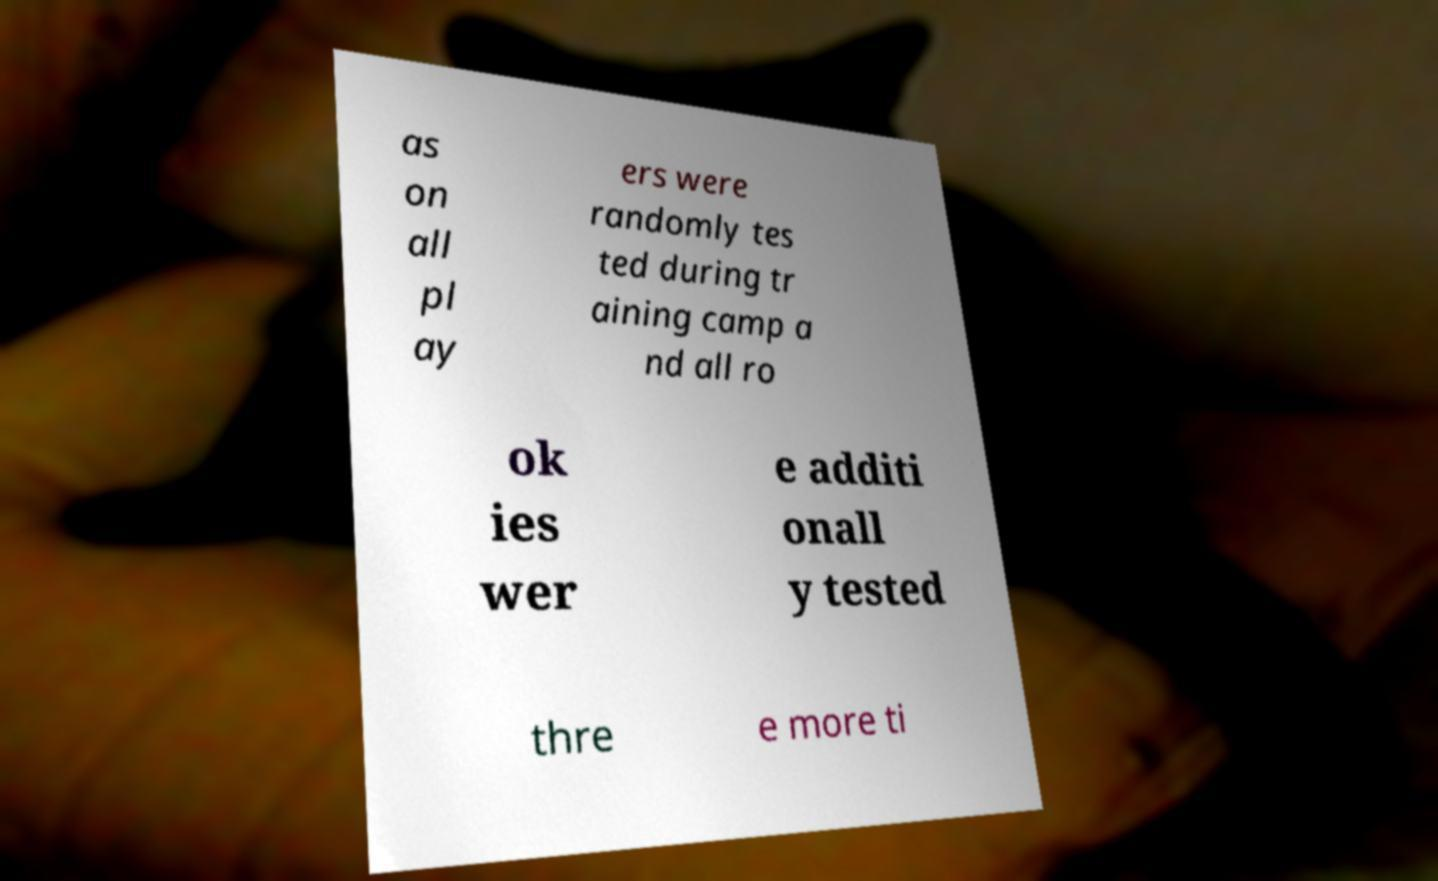Please identify and transcribe the text found in this image. as on all pl ay ers were randomly tes ted during tr aining camp a nd all ro ok ies wer e additi onall y tested thre e more ti 